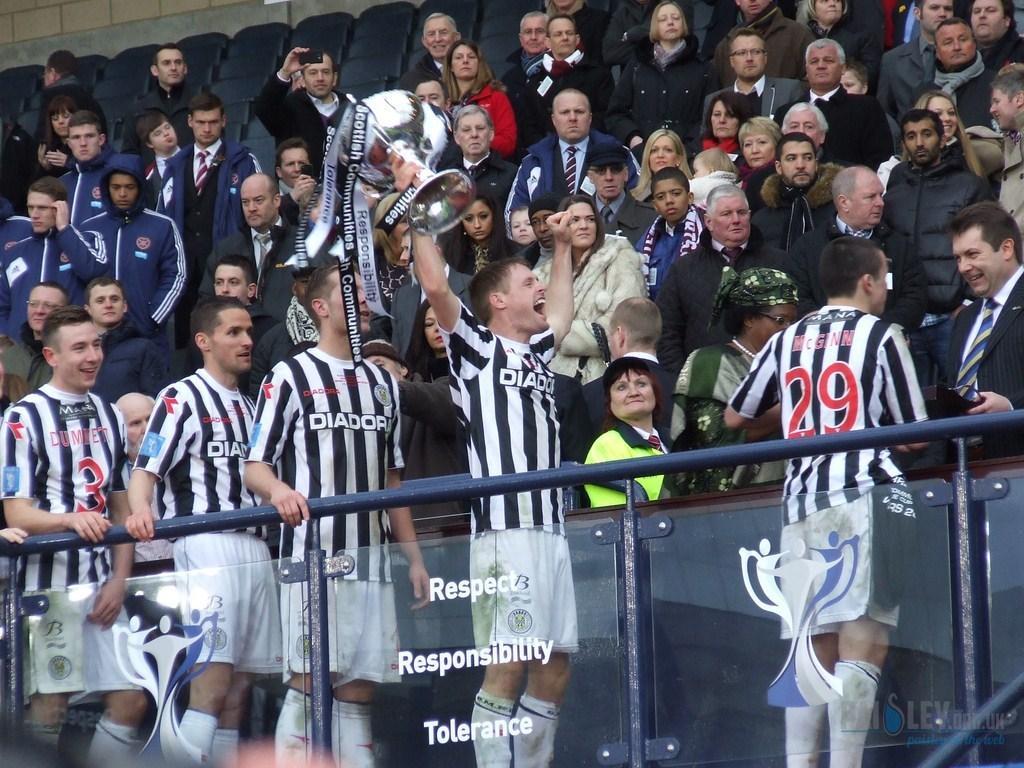Please provide a concise description of this image. In this image we can see people standing in stands. In the foreground of the image there is glass railing with some text on it. There are people wearing black and white color T-shirts. In the center of the image there is a person holding a cup in his hand. In the background of the image there are seats. 